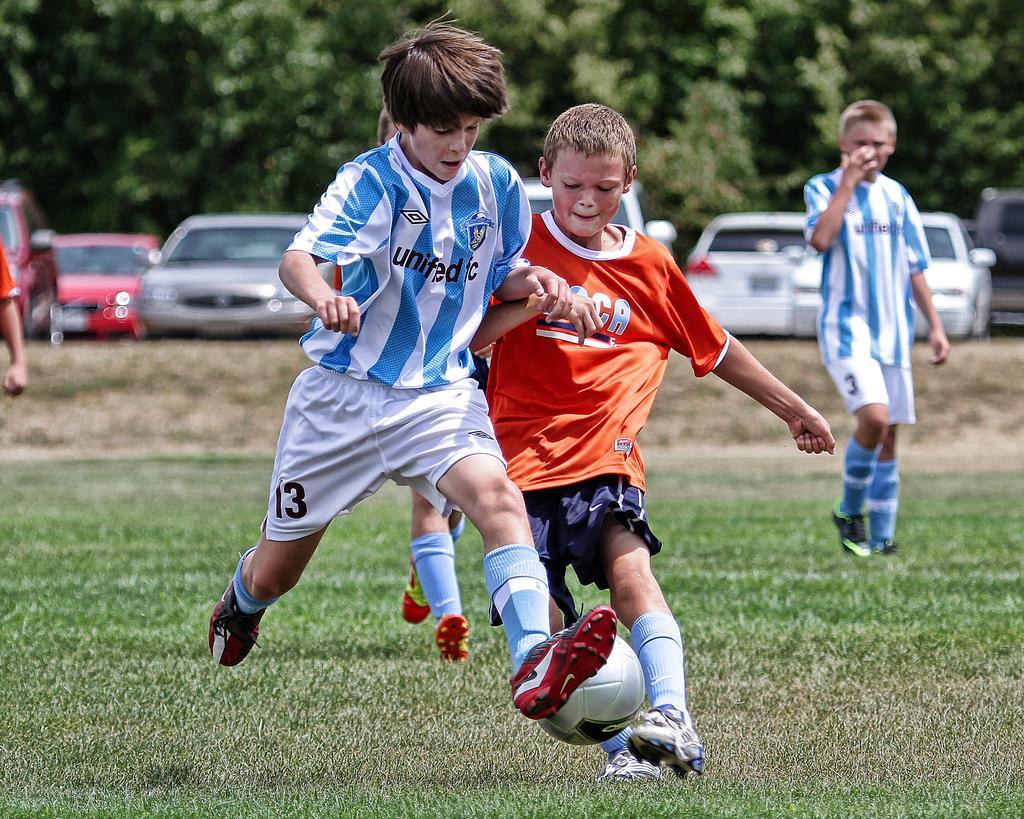Can you describe this image briefly? This image is clicked in a ground where there are four children, they are playing a game. There is a ball in the bottom. There are trees on the top. There are cars in the middle. 